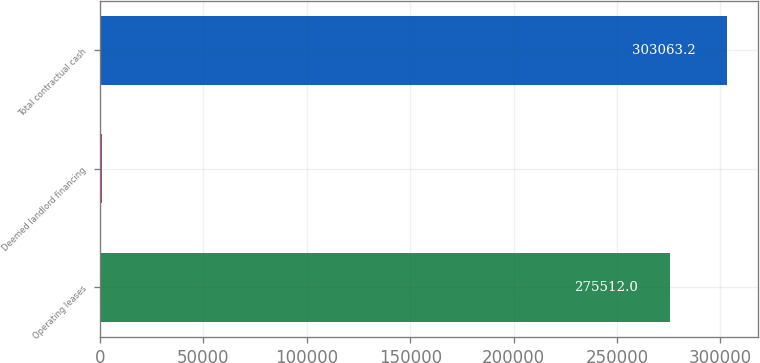<chart> <loc_0><loc_0><loc_500><loc_500><bar_chart><fcel>Operating leases<fcel>Deemed landlord financing<fcel>Total contractual cash<nl><fcel>275512<fcel>821<fcel>303063<nl></chart> 